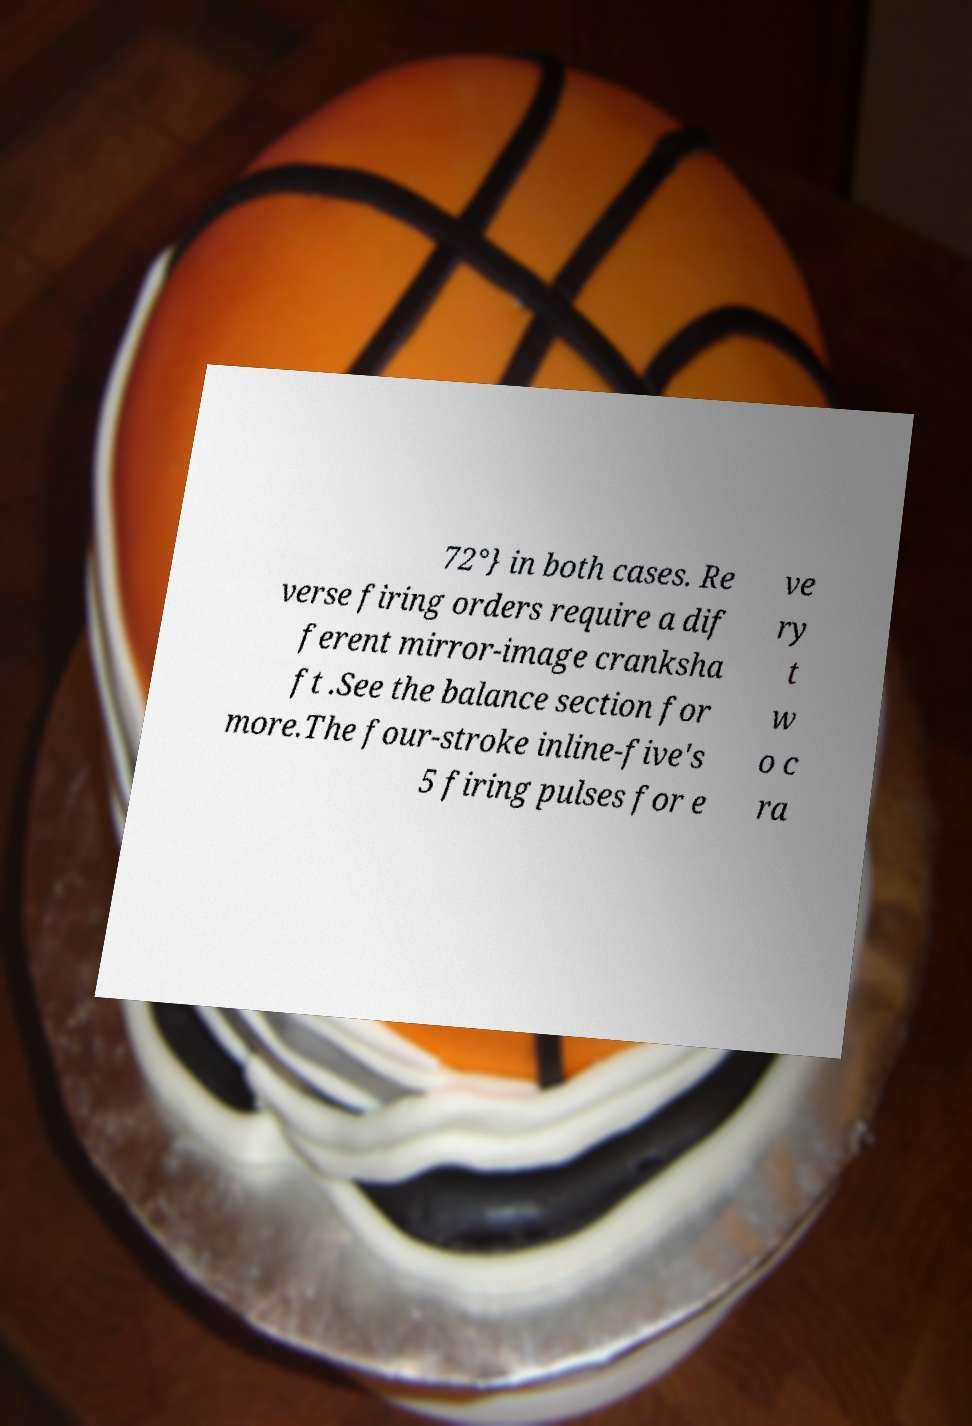Could you extract and type out the text from this image? 72°} in both cases. Re verse firing orders require a dif ferent mirror-image cranksha ft .See the balance section for more.The four-stroke inline-five's 5 firing pulses for e ve ry t w o c ra 